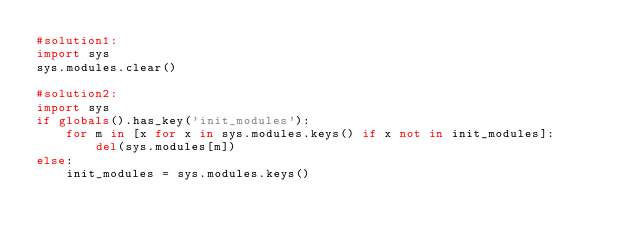<code> <loc_0><loc_0><loc_500><loc_500><_Python_>#solution1:
import sys
sys.modules.clear()

#solution2:
import sys
if globals().has_key('init_modules'):
	for m in [x for x in sys.modules.keys() if x not in init_modules]:
		del(sys.modules[m]) 
else:
	init_modules = sys.modules.keys()
</code> 